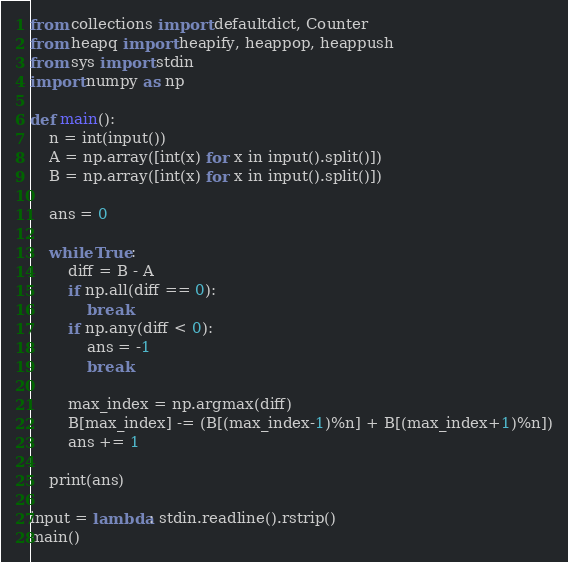Convert code to text. <code><loc_0><loc_0><loc_500><loc_500><_Python_>from collections import defaultdict, Counter
from heapq import heapify, heappop, heappush
from sys import stdin
import numpy as np

def main():
    n = int(input())
    A = np.array([int(x) for x in input().split()])
    B = np.array([int(x) for x in input().split()])

    ans = 0

    while True:
        diff = B - A
        if np.all(diff == 0):
            break
        if np.any(diff < 0):
            ans = -1
            break

        max_index = np.argmax(diff)
        B[max_index] -= (B[(max_index-1)%n] + B[(max_index+1)%n])
        ans += 1

    print(ans)

input = lambda: stdin.readline().rstrip()
main()</code> 